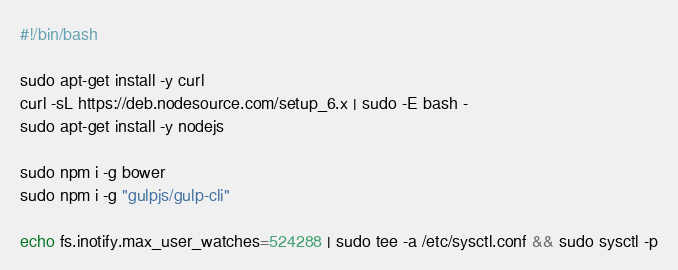Convert code to text. <code><loc_0><loc_0><loc_500><loc_500><_Bash_>#!/bin/bash

sudo apt-get install -y curl
curl -sL https://deb.nodesource.com/setup_6.x | sudo -E bash -
sudo apt-get install -y nodejs

sudo npm i -g bower
sudo npm i -g "gulpjs/gulp-cli"

echo fs.inotify.max_user_watches=524288 | sudo tee -a /etc/sysctl.conf && sudo sysctl -p
</code> 